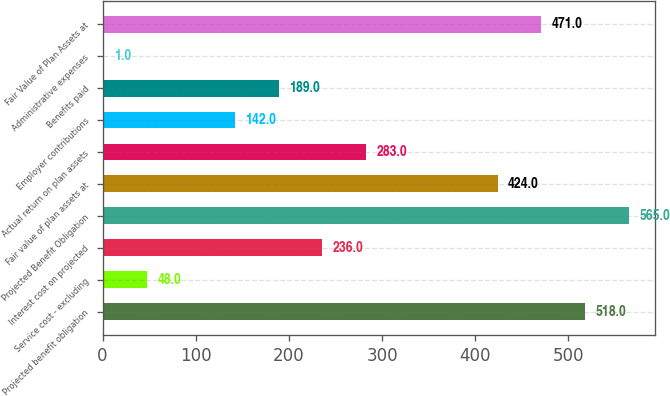Convert chart to OTSL. <chart><loc_0><loc_0><loc_500><loc_500><bar_chart><fcel>Projected benefit obligation<fcel>Service cost - excluding<fcel>Interest cost on projected<fcel>Projected Benefit Obligation<fcel>Fair value of plan assets at<fcel>Actual return on plan assets<fcel>Employer contributions<fcel>Benefits paid<fcel>Administrative expenses<fcel>Fair Value of Plan Assets at<nl><fcel>518<fcel>48<fcel>236<fcel>565<fcel>424<fcel>283<fcel>142<fcel>189<fcel>1<fcel>471<nl></chart> 